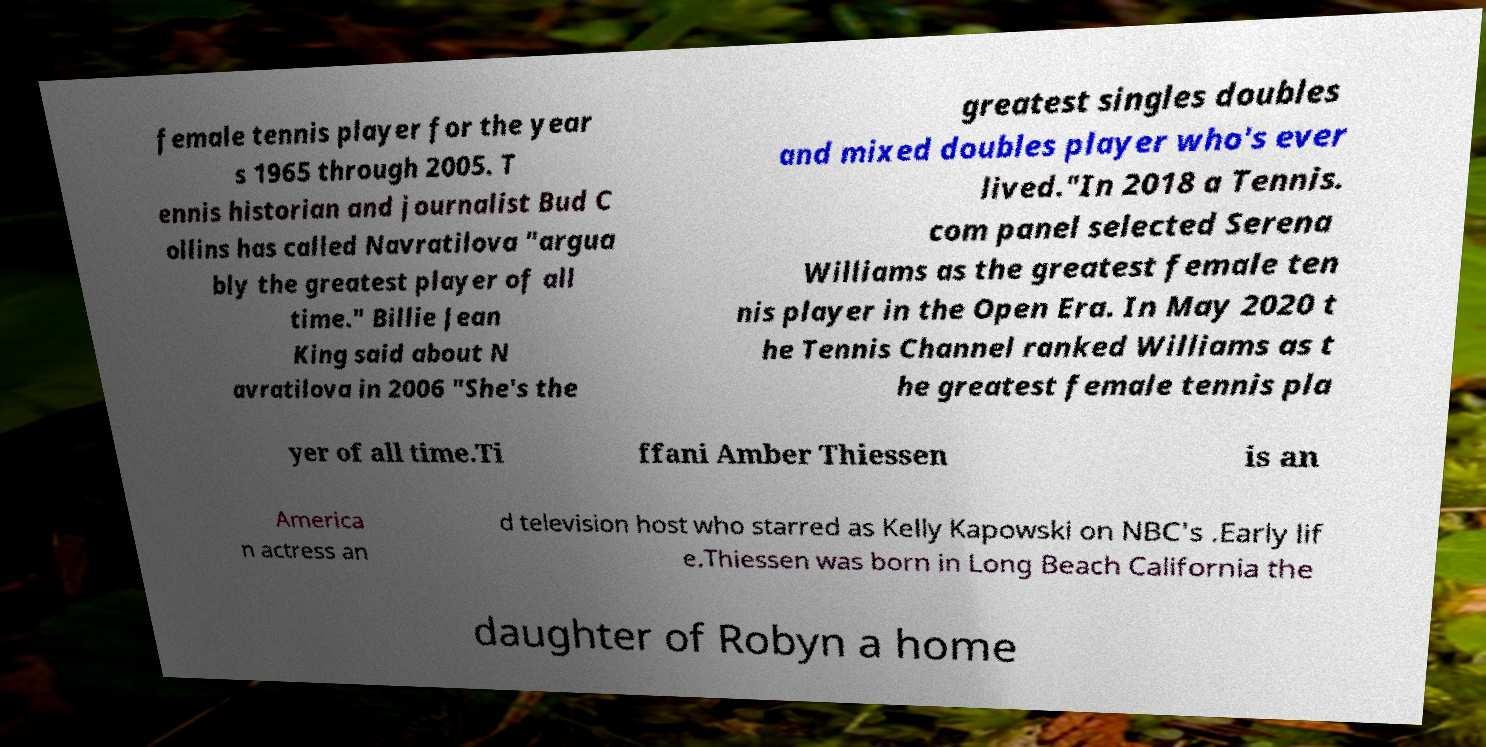I need the written content from this picture converted into text. Can you do that? female tennis player for the year s 1965 through 2005. T ennis historian and journalist Bud C ollins has called Navratilova "argua bly the greatest player of all time." Billie Jean King said about N avratilova in 2006 "She's the greatest singles doubles and mixed doubles player who's ever lived."In 2018 a Tennis. com panel selected Serena Williams as the greatest female ten nis player in the Open Era. In May 2020 t he Tennis Channel ranked Williams as t he greatest female tennis pla yer of all time.Ti ffani Amber Thiessen is an America n actress an d television host who starred as Kelly Kapowski on NBC's .Early lif e.Thiessen was born in Long Beach California the daughter of Robyn a home 